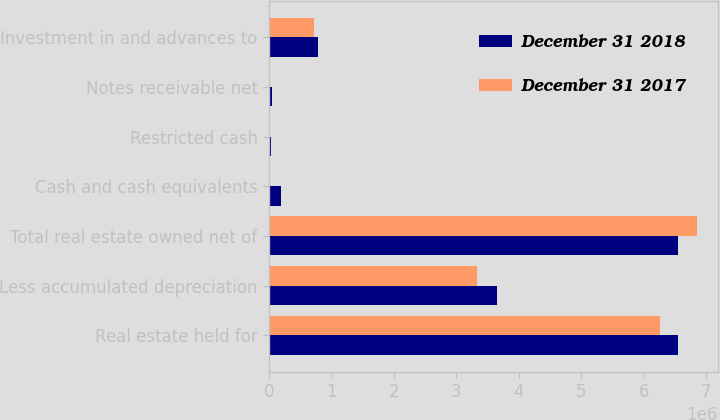Convert chart to OTSL. <chart><loc_0><loc_0><loc_500><loc_500><stacked_bar_chart><ecel><fcel>Real estate held for<fcel>Less accumulated depreciation<fcel>Total real estate owned net of<fcel>Cash and cash equivalents<fcel>Restricted cash<fcel>Notes receivable net<fcel>Investment in and advances to<nl><fcel>December 31 2018<fcel>6.542e+06<fcel>3.65416e+06<fcel>6.542e+06<fcel>185216<fcel>23675<fcel>42259<fcel>780869<nl><fcel>December 31 2017<fcel>6.2584e+06<fcel>3.32631e+06<fcel>6.84704e+06<fcel>2038<fcel>19792<fcel>19469<fcel>720830<nl></chart> 